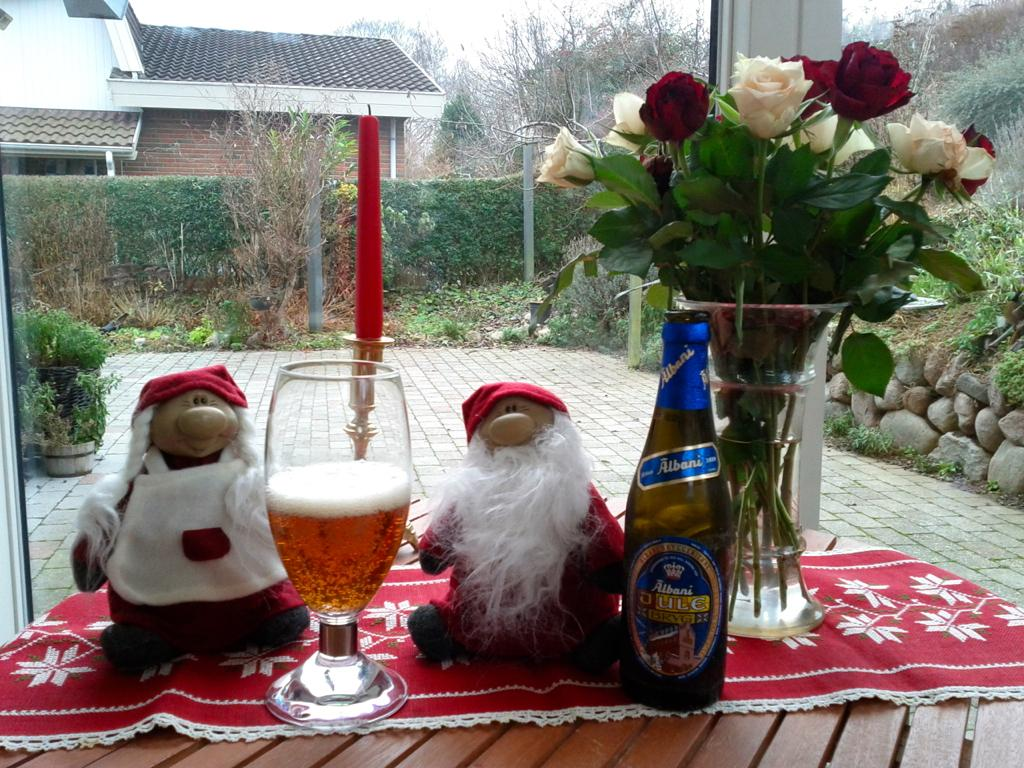How many toys are visible in the image? There are 2 toys in the image. What type of glassware is present in the image? There is a wine glass in the image. What type of alcoholic beverage is associated with the wine glass? There is a wine bottle in the image. What type of fabric is present in the image? There is a cloth in the image. What type of decorative item is present in the image? There is a flower bouquet in the image. What type of container is present in the image? There is a pot in the image. What type of lighting is present in the image? There is a candle in the image. Where are the objects located in the image? The objects are on a table. What type of background can be seen in the image? There is a house, a plant, grass, and trees in the background of the image. What type of elbow is visible in the image? There is no elbow present in the image. What type of rose can be seen in the image? There is no rose present in the image. 